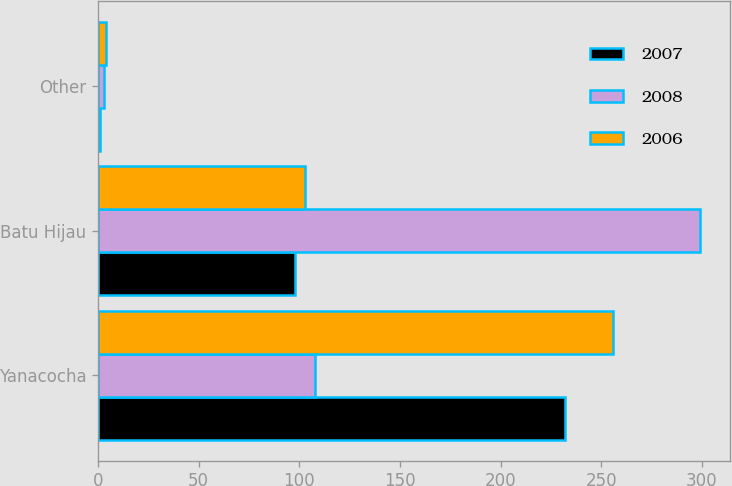Convert chart. <chart><loc_0><loc_0><loc_500><loc_500><stacked_bar_chart><ecel><fcel>Yanacocha<fcel>Batu Hijau<fcel>Other<nl><fcel>2007<fcel>232<fcel>98<fcel>1<nl><fcel>2008<fcel>108<fcel>299<fcel>3<nl><fcel>2006<fcel>256<fcel>103<fcel>4<nl></chart> 